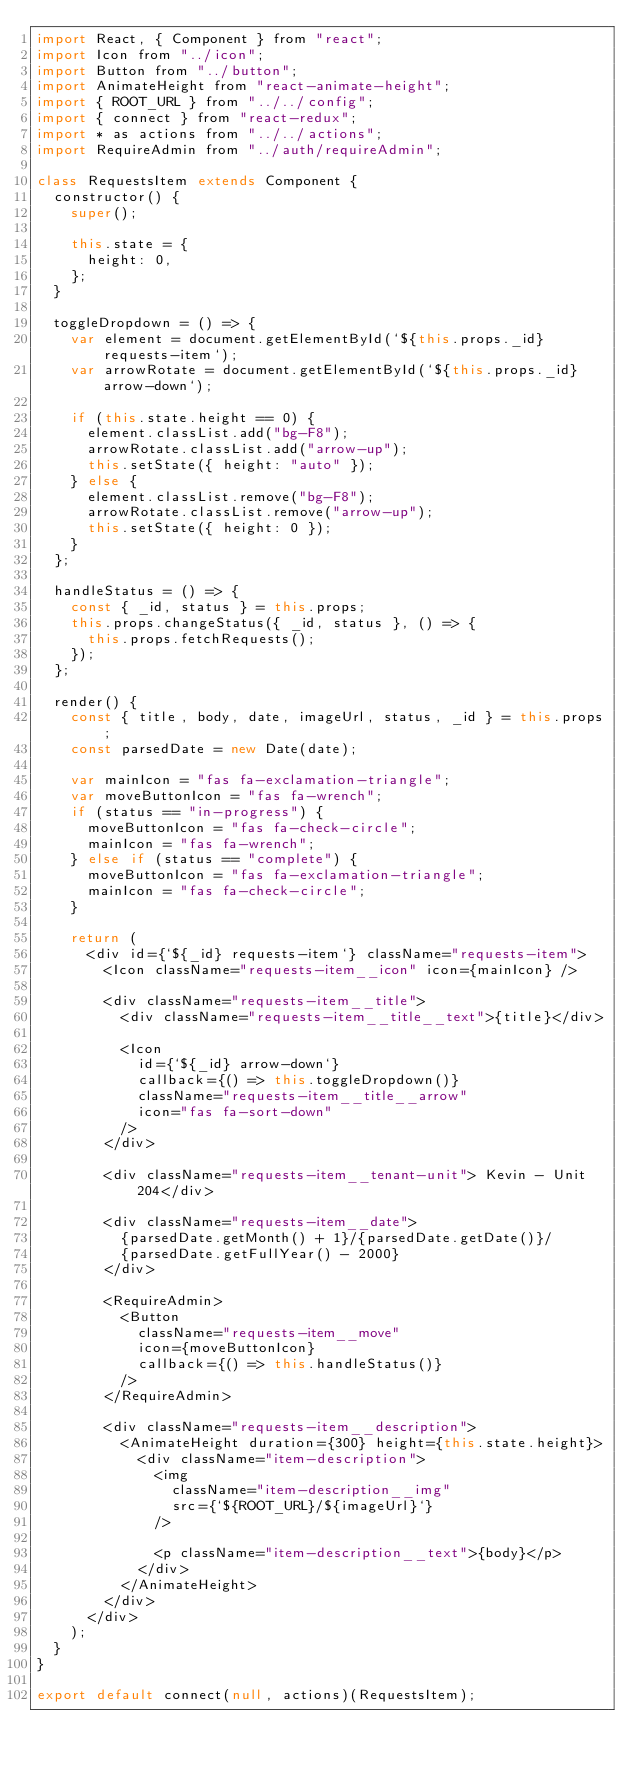<code> <loc_0><loc_0><loc_500><loc_500><_JavaScript_>import React, { Component } from "react";
import Icon from "../icon";
import Button from "../button";
import AnimateHeight from "react-animate-height";
import { ROOT_URL } from "../../config";
import { connect } from "react-redux";
import * as actions from "../../actions";
import RequireAdmin from "../auth/requireAdmin";

class RequestsItem extends Component {
  constructor() {
    super();

    this.state = {
      height: 0,
    };
  }

  toggleDropdown = () => {
    var element = document.getElementById(`${this.props._id} requests-item`);
    var arrowRotate = document.getElementById(`${this.props._id} arrow-down`);

    if (this.state.height == 0) {
      element.classList.add("bg-F8");
      arrowRotate.classList.add("arrow-up");
      this.setState({ height: "auto" });
    } else {
      element.classList.remove("bg-F8");
      arrowRotate.classList.remove("arrow-up");
      this.setState({ height: 0 });
    }
  };

  handleStatus = () => {
    const { _id, status } = this.props;
    this.props.changeStatus({ _id, status }, () => {
      this.props.fetchRequests();
    });
  };

  render() {
    const { title, body, date, imageUrl, status, _id } = this.props;
    const parsedDate = new Date(date);

    var mainIcon = "fas fa-exclamation-triangle";
    var moveButtonIcon = "fas fa-wrench";
    if (status == "in-progress") {
      moveButtonIcon = "fas fa-check-circle";
      mainIcon = "fas fa-wrench";
    } else if (status == "complete") {
      moveButtonIcon = "fas fa-exclamation-triangle";
      mainIcon = "fas fa-check-circle";
    }

    return (
      <div id={`${_id} requests-item`} className="requests-item">
        <Icon className="requests-item__icon" icon={mainIcon} />

        <div className="requests-item__title">
          <div className="requests-item__title__text">{title}</div>

          <Icon
            id={`${_id} arrow-down`}
            callback={() => this.toggleDropdown()}
            className="requests-item__title__arrow"
            icon="fas fa-sort-down"
          />
        </div>

        <div className="requests-item__tenant-unit"> Kevin - Unit 204</div>

        <div className="requests-item__date">
          {parsedDate.getMonth() + 1}/{parsedDate.getDate()}/
          {parsedDate.getFullYear() - 2000}
        </div>

        <RequireAdmin>
          <Button
            className="requests-item__move"
            icon={moveButtonIcon}
            callback={() => this.handleStatus()}
          />
        </RequireAdmin>

        <div className="requests-item__description">
          <AnimateHeight duration={300} height={this.state.height}>
            <div className="item-description">
              <img
                className="item-description__img"
                src={`${ROOT_URL}/${imageUrl}`}
              />

              <p className="item-description__text">{body}</p>
            </div>
          </AnimateHeight>
        </div>
      </div>
    );
  }
}

export default connect(null, actions)(RequestsItem);
</code> 